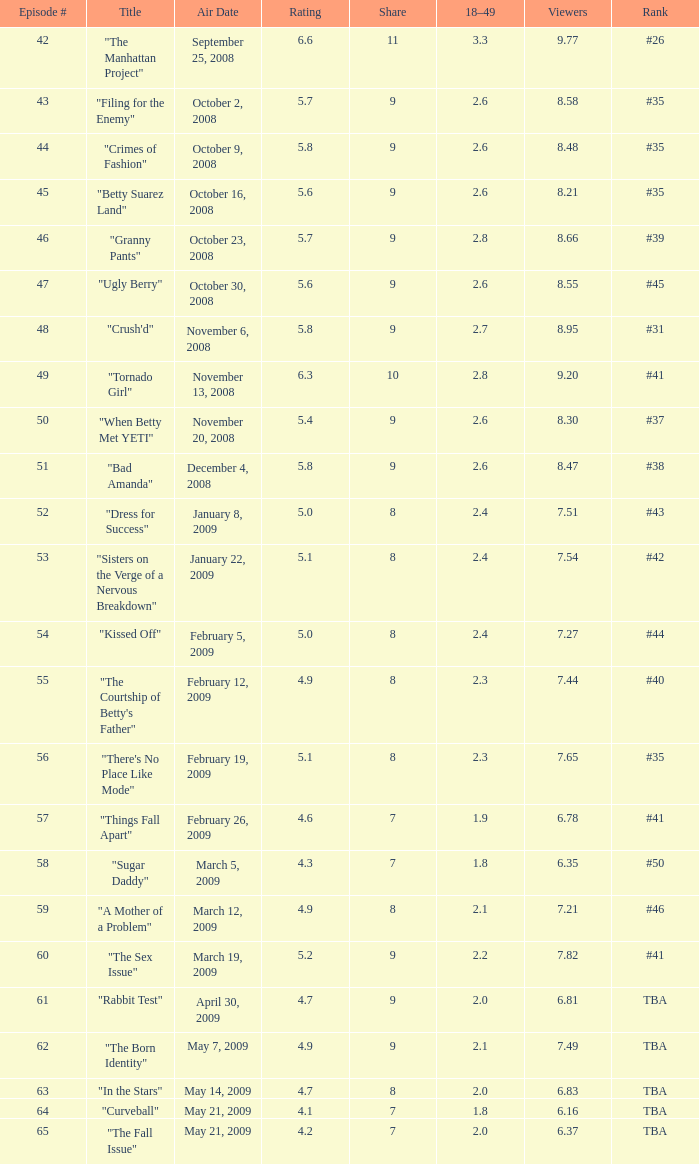9, under April 30, 2009, May 14, 2009, May 21, 2009. 